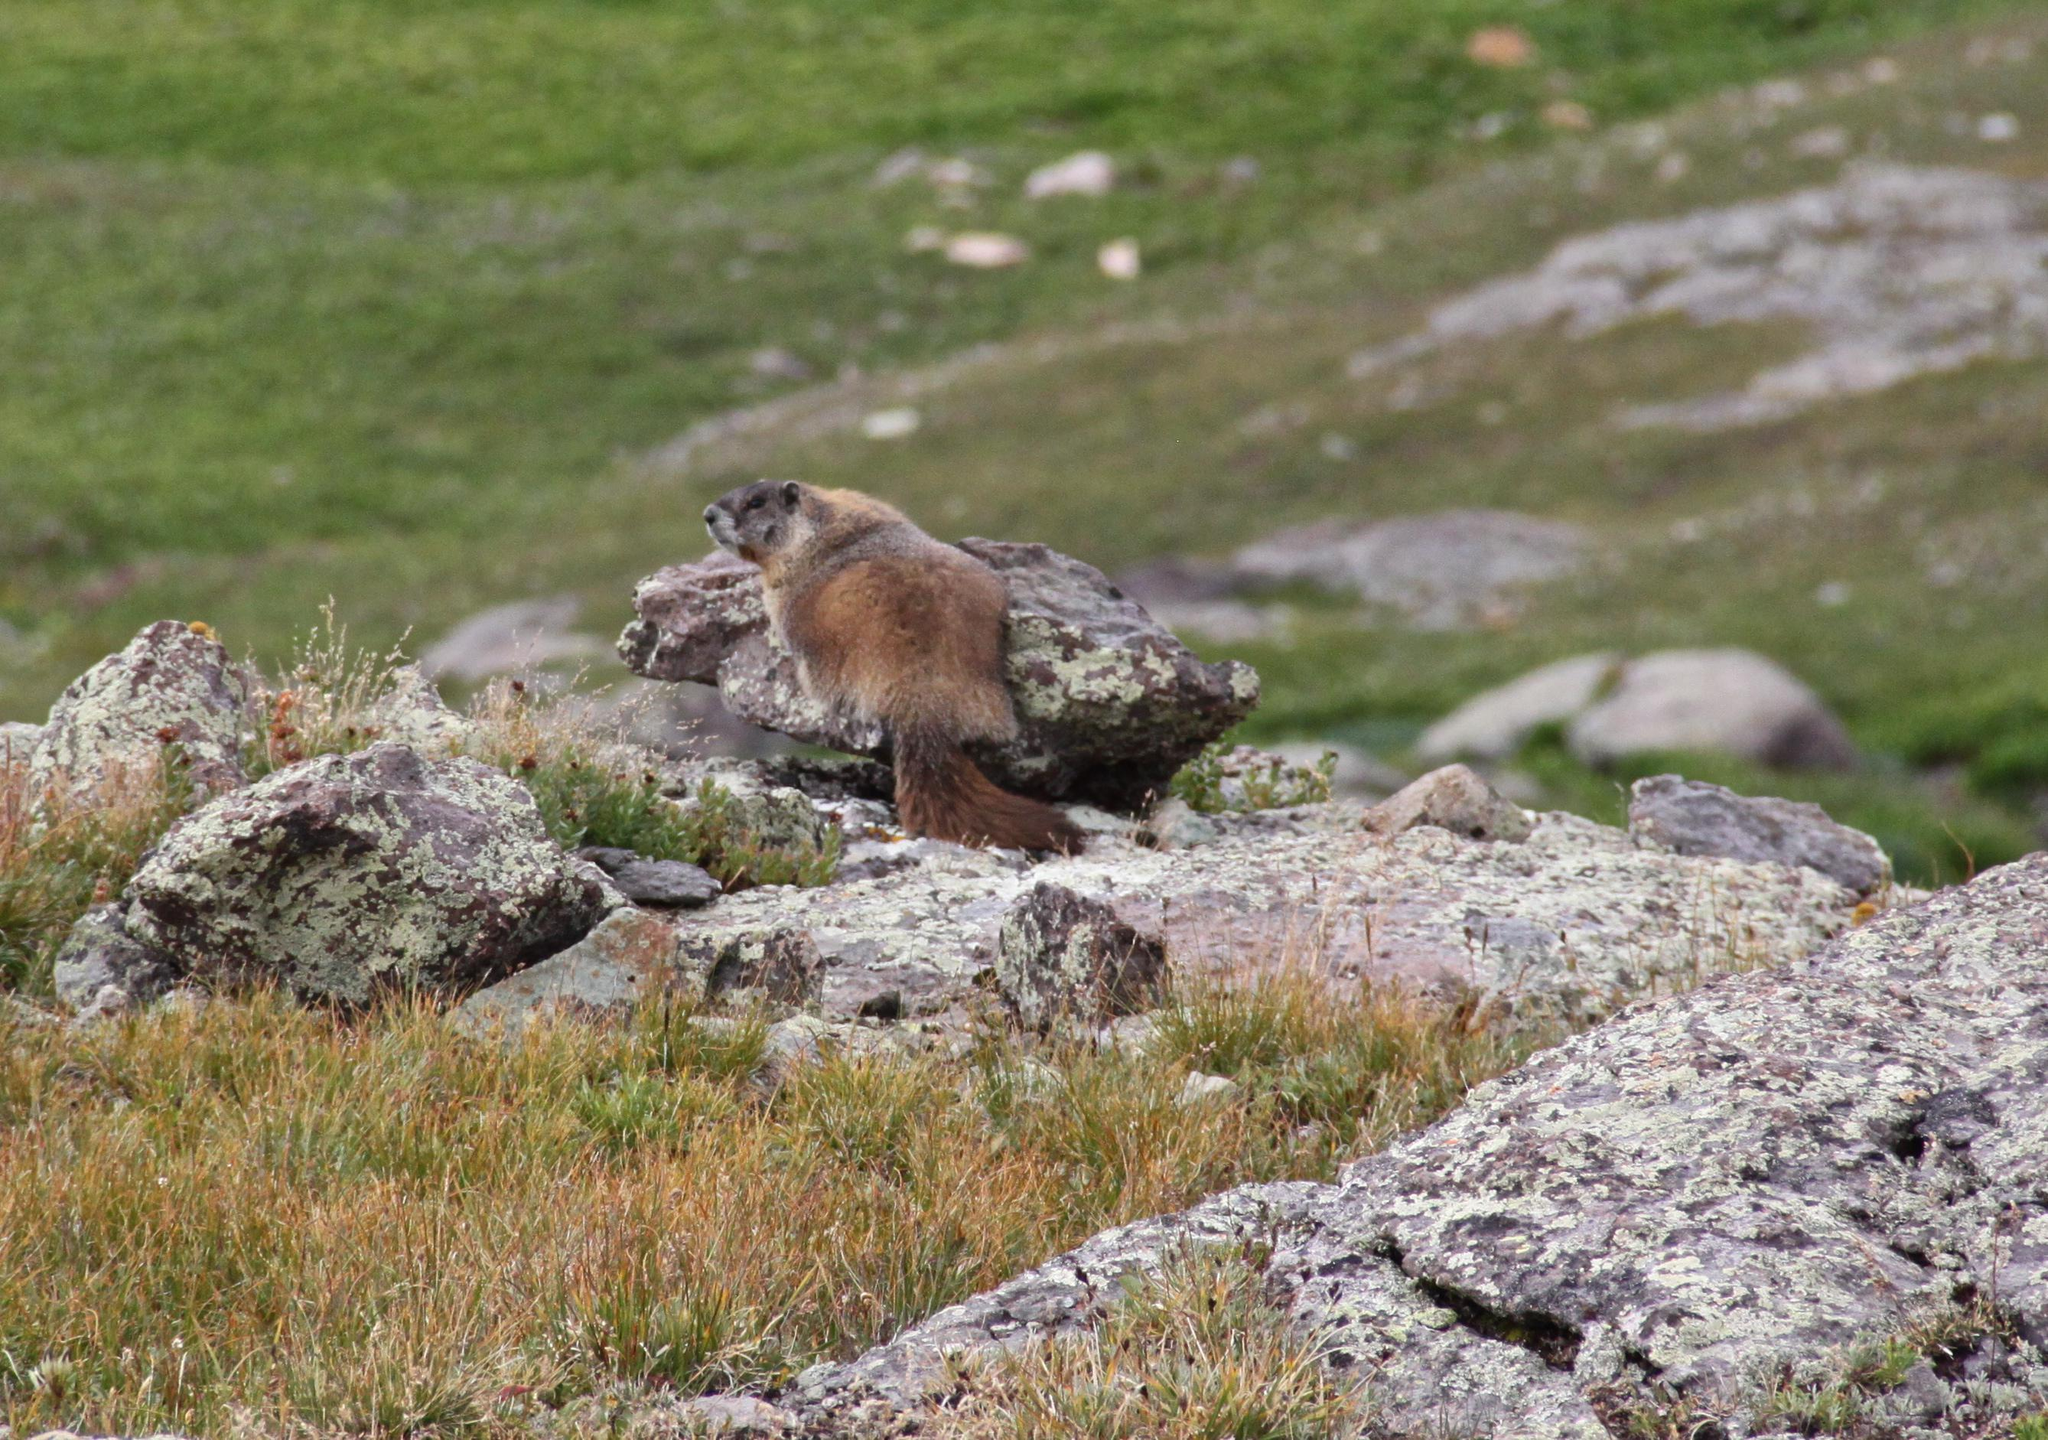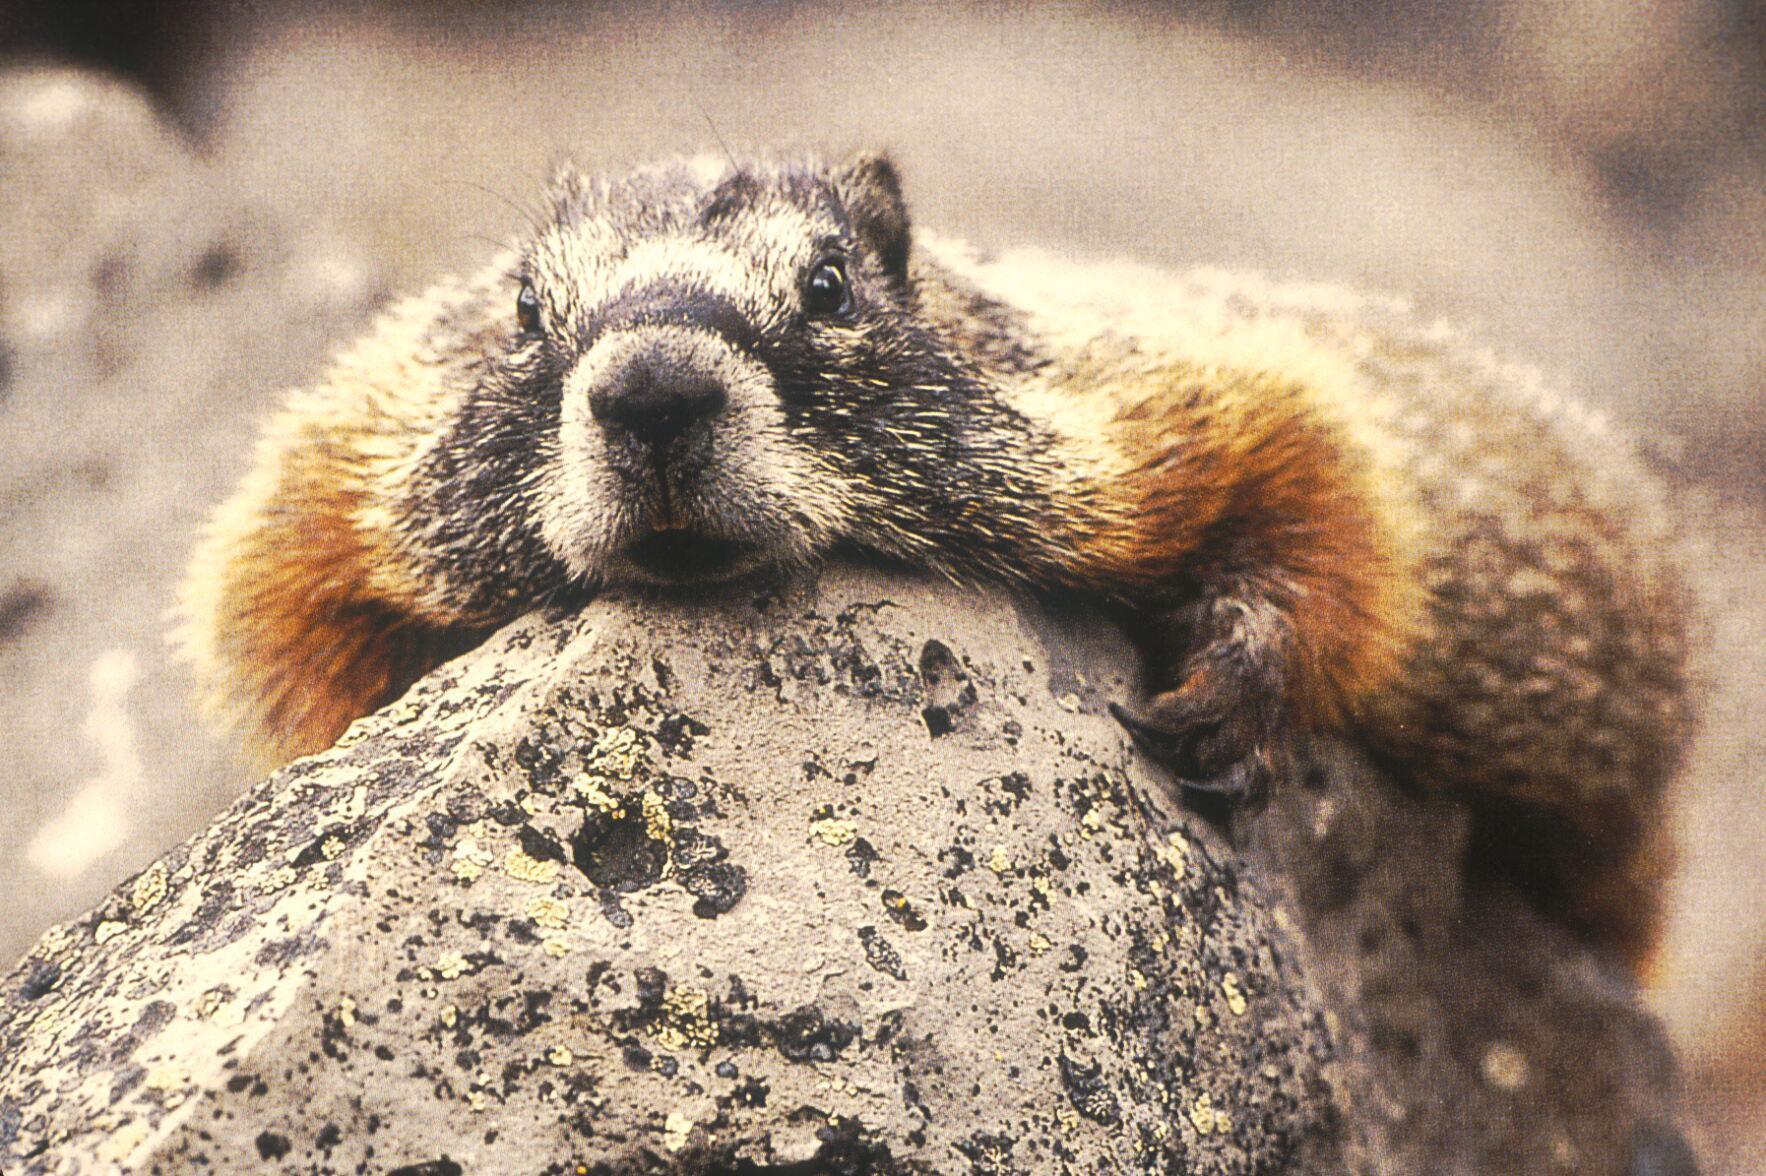The first image is the image on the left, the second image is the image on the right. For the images displayed, is the sentence "The animal in the image on the right is looking toward the camera" factually correct? Answer yes or no. Yes. 